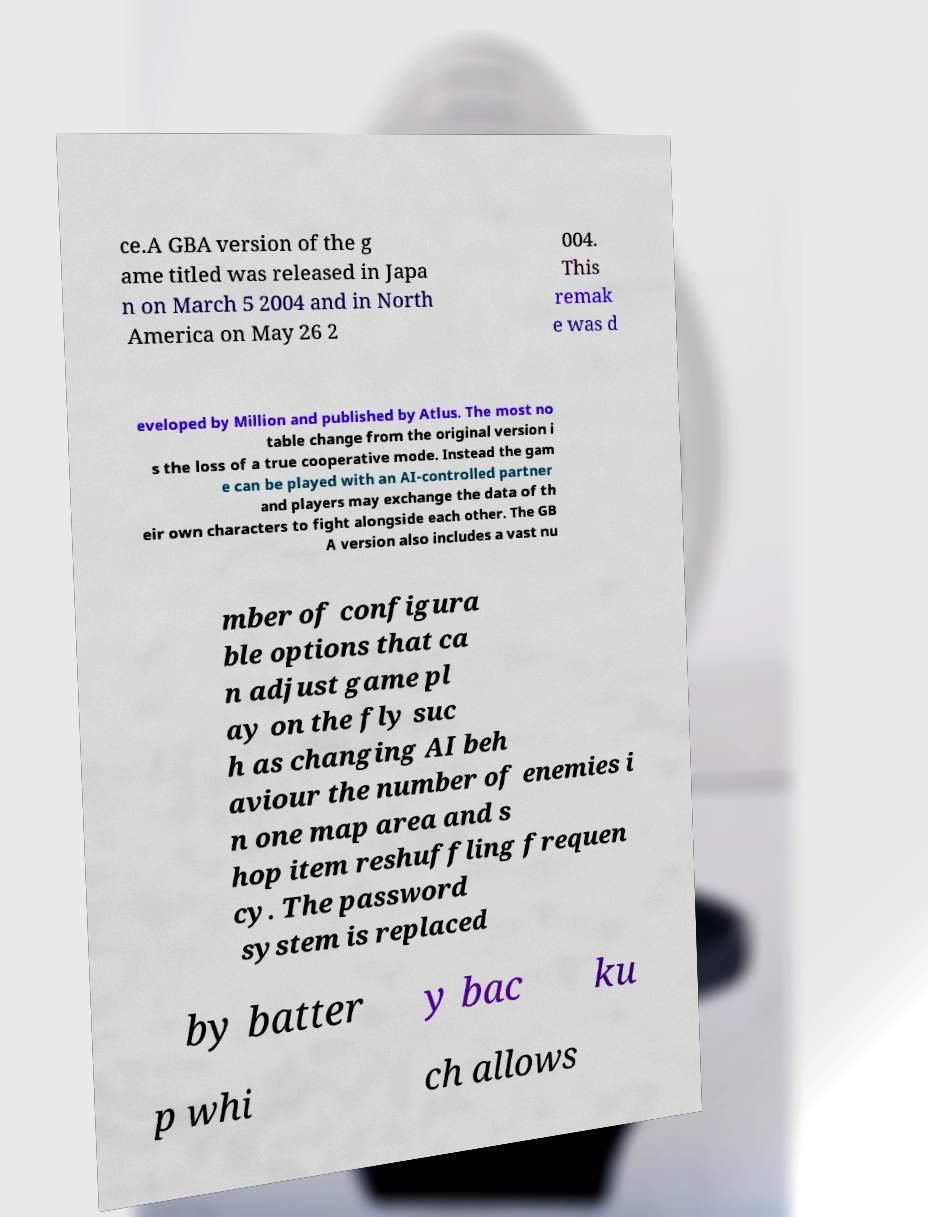I need the written content from this picture converted into text. Can you do that? ce.A GBA version of the g ame titled was released in Japa n on March 5 2004 and in North America on May 26 2 004. This remak e was d eveloped by Million and published by Atlus. The most no table change from the original version i s the loss of a true cooperative mode. Instead the gam e can be played with an AI-controlled partner and players may exchange the data of th eir own characters to fight alongside each other. The GB A version also includes a vast nu mber of configura ble options that ca n adjust game pl ay on the fly suc h as changing AI beh aviour the number of enemies i n one map area and s hop item reshuffling frequen cy. The password system is replaced by batter y bac ku p whi ch allows 